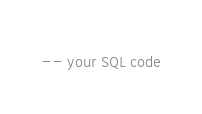Convert code to text. <code><loc_0><loc_0><loc_500><loc_500><_SQL_>-- your SQL code</code> 